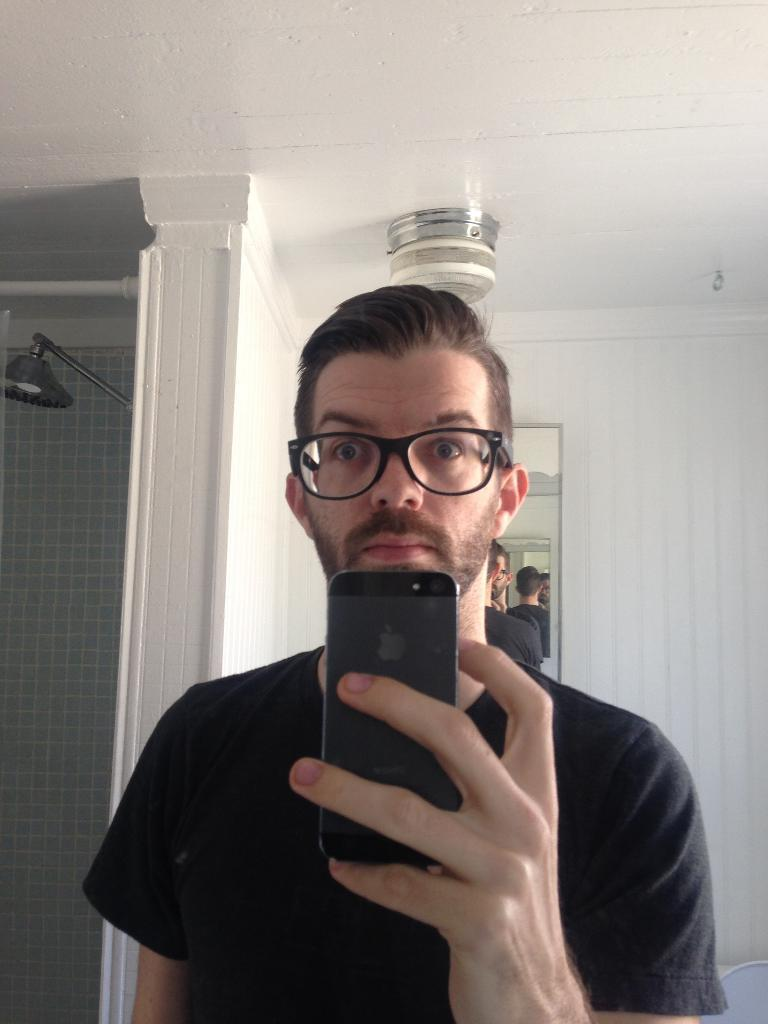What is the man in the image doing? The man is standing in the image. What object is the man holding? The man is holding a mobile in the image. What can be seen in the background of the image? There is a shower and a mirror attached to a wall in the background of the image. How does the man's digestion process appear in the image? There is no indication of the man's digestion process in the image. 